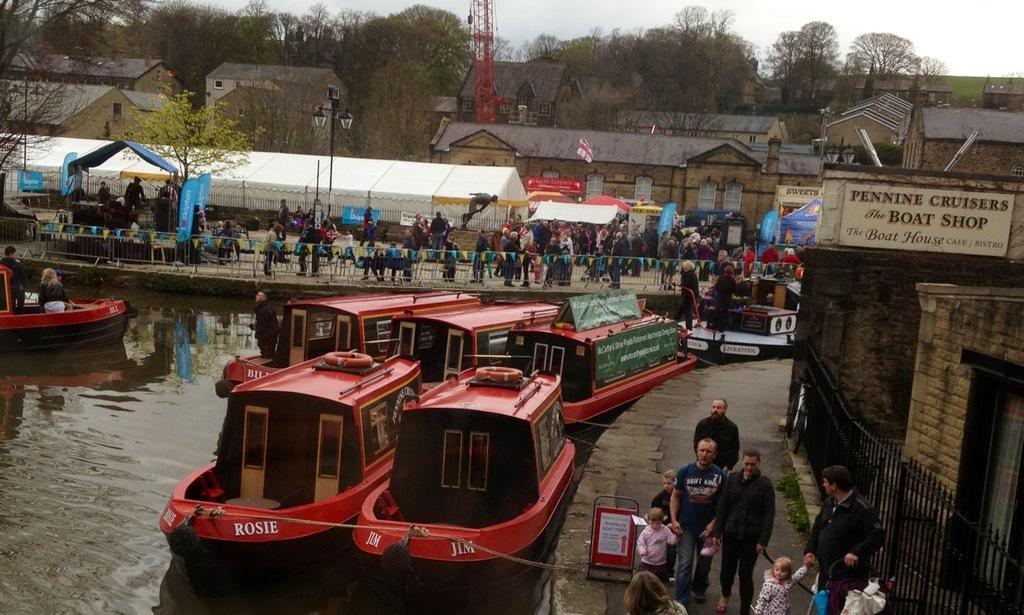What type of vehicles can be seen in the image? There are boats in the image. What type of structures are present in the image? There are buildings in the image. What architectural feature can be seen in the image? The image contains windows. What type of vegetation is present in the image? Trees are present in the image. What type of street furniture can be seen in the image? Light poles are visible in the image. What type of barrier is present in the image? There is fencing in the image. What type of construction equipment is present in the image? A crane is present in the image. What type of material is visible in the image? Boards are visible in the image. What type of natural feature is present in the image? Water is visible in the image. What type of activity can be seen in the image? People are walking in the image. What is the color of the sky in the image? The sky is white and blue in color. What type of health advice can be seen on the boards in the image? There is no health advice present on the boards in the image. What type of secretary can be seen working in one of the buildings in the image? There is no secretary present in the image. What type of kettle is visible on the table in the image? There is no kettle present in the image. 